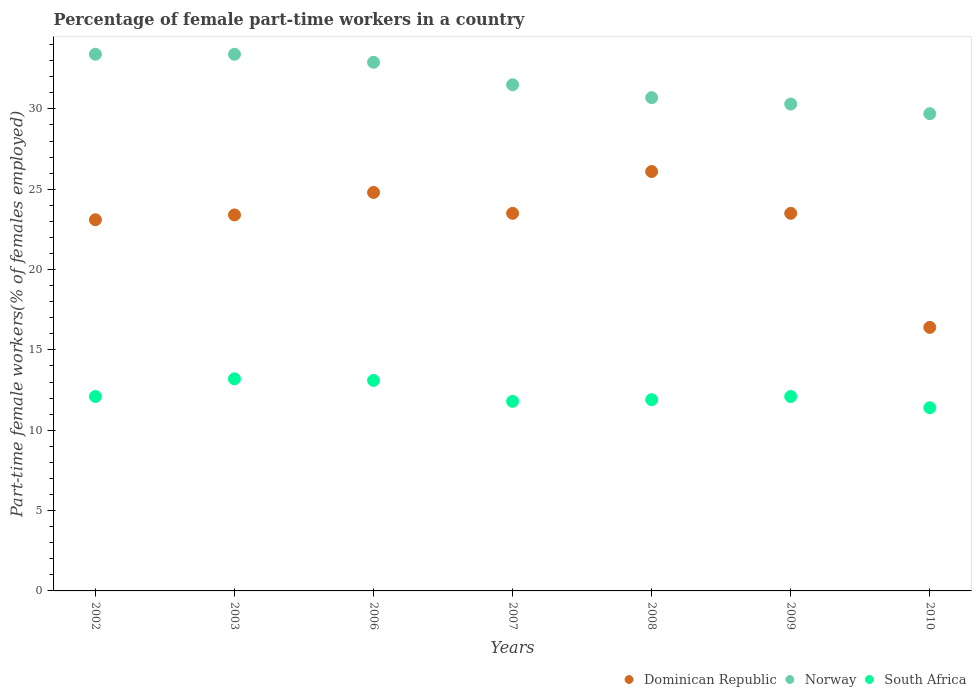How many different coloured dotlines are there?
Provide a succinct answer. 3. Is the number of dotlines equal to the number of legend labels?
Your answer should be compact. Yes. What is the percentage of female part-time workers in Norway in 2007?
Your response must be concise. 31.5. Across all years, what is the maximum percentage of female part-time workers in Norway?
Ensure brevity in your answer.  33.4. Across all years, what is the minimum percentage of female part-time workers in Norway?
Your answer should be compact. 29.7. In which year was the percentage of female part-time workers in Dominican Republic minimum?
Ensure brevity in your answer.  2010. What is the total percentage of female part-time workers in Norway in the graph?
Ensure brevity in your answer.  221.9. What is the difference between the percentage of female part-time workers in Dominican Republic in 2002 and that in 2008?
Ensure brevity in your answer.  -3. What is the difference between the percentage of female part-time workers in Norway in 2006 and the percentage of female part-time workers in South Africa in 2007?
Make the answer very short. 21.1. What is the average percentage of female part-time workers in Norway per year?
Offer a very short reply. 31.7. In the year 2002, what is the difference between the percentage of female part-time workers in Norway and percentage of female part-time workers in South Africa?
Provide a succinct answer. 21.3. What is the ratio of the percentage of female part-time workers in South Africa in 2003 to that in 2010?
Your response must be concise. 1.16. Is the percentage of female part-time workers in South Africa in 2002 less than that in 2009?
Your answer should be very brief. No. Is the difference between the percentage of female part-time workers in Norway in 2003 and 2007 greater than the difference between the percentage of female part-time workers in South Africa in 2003 and 2007?
Your answer should be very brief. Yes. What is the difference between the highest and the second highest percentage of female part-time workers in South Africa?
Provide a succinct answer. 0.1. What is the difference between the highest and the lowest percentage of female part-time workers in South Africa?
Offer a terse response. 1.8. Is the sum of the percentage of female part-time workers in Dominican Republic in 2003 and 2006 greater than the maximum percentage of female part-time workers in Norway across all years?
Your response must be concise. Yes. Is it the case that in every year, the sum of the percentage of female part-time workers in Norway and percentage of female part-time workers in South Africa  is greater than the percentage of female part-time workers in Dominican Republic?
Provide a short and direct response. Yes. Does the percentage of female part-time workers in South Africa monotonically increase over the years?
Your answer should be compact. No. Is the percentage of female part-time workers in South Africa strictly less than the percentage of female part-time workers in Norway over the years?
Keep it short and to the point. Yes. Are the values on the major ticks of Y-axis written in scientific E-notation?
Make the answer very short. No. Where does the legend appear in the graph?
Your answer should be very brief. Bottom right. How many legend labels are there?
Offer a terse response. 3. How are the legend labels stacked?
Your answer should be compact. Horizontal. What is the title of the graph?
Your response must be concise. Percentage of female part-time workers in a country. Does "Canada" appear as one of the legend labels in the graph?
Your response must be concise. No. What is the label or title of the Y-axis?
Offer a very short reply. Part-time female workers(% of females employed). What is the Part-time female workers(% of females employed) of Dominican Republic in 2002?
Ensure brevity in your answer.  23.1. What is the Part-time female workers(% of females employed) in Norway in 2002?
Your answer should be very brief. 33.4. What is the Part-time female workers(% of females employed) in South Africa in 2002?
Ensure brevity in your answer.  12.1. What is the Part-time female workers(% of females employed) in Dominican Republic in 2003?
Give a very brief answer. 23.4. What is the Part-time female workers(% of females employed) in Norway in 2003?
Offer a very short reply. 33.4. What is the Part-time female workers(% of females employed) of South Africa in 2003?
Offer a very short reply. 13.2. What is the Part-time female workers(% of females employed) of Dominican Republic in 2006?
Provide a succinct answer. 24.8. What is the Part-time female workers(% of females employed) of Norway in 2006?
Give a very brief answer. 32.9. What is the Part-time female workers(% of females employed) of South Africa in 2006?
Give a very brief answer. 13.1. What is the Part-time female workers(% of females employed) in Dominican Republic in 2007?
Make the answer very short. 23.5. What is the Part-time female workers(% of females employed) in Norway in 2007?
Provide a short and direct response. 31.5. What is the Part-time female workers(% of females employed) in South Africa in 2007?
Offer a very short reply. 11.8. What is the Part-time female workers(% of females employed) of Dominican Republic in 2008?
Provide a short and direct response. 26.1. What is the Part-time female workers(% of females employed) of Norway in 2008?
Your answer should be very brief. 30.7. What is the Part-time female workers(% of females employed) in South Africa in 2008?
Provide a succinct answer. 11.9. What is the Part-time female workers(% of females employed) of Norway in 2009?
Provide a succinct answer. 30.3. What is the Part-time female workers(% of females employed) in South Africa in 2009?
Offer a very short reply. 12.1. What is the Part-time female workers(% of females employed) of Dominican Republic in 2010?
Offer a very short reply. 16.4. What is the Part-time female workers(% of females employed) in Norway in 2010?
Provide a short and direct response. 29.7. What is the Part-time female workers(% of females employed) of South Africa in 2010?
Give a very brief answer. 11.4. Across all years, what is the maximum Part-time female workers(% of females employed) of Dominican Republic?
Give a very brief answer. 26.1. Across all years, what is the maximum Part-time female workers(% of females employed) of Norway?
Your answer should be compact. 33.4. Across all years, what is the maximum Part-time female workers(% of females employed) of South Africa?
Your answer should be compact. 13.2. Across all years, what is the minimum Part-time female workers(% of females employed) of Dominican Republic?
Make the answer very short. 16.4. Across all years, what is the minimum Part-time female workers(% of females employed) of Norway?
Give a very brief answer. 29.7. Across all years, what is the minimum Part-time female workers(% of females employed) of South Africa?
Provide a short and direct response. 11.4. What is the total Part-time female workers(% of females employed) of Dominican Republic in the graph?
Offer a very short reply. 160.8. What is the total Part-time female workers(% of females employed) of Norway in the graph?
Your response must be concise. 221.9. What is the total Part-time female workers(% of females employed) in South Africa in the graph?
Your answer should be compact. 85.6. What is the difference between the Part-time female workers(% of females employed) of Dominican Republic in 2002 and that in 2003?
Provide a short and direct response. -0.3. What is the difference between the Part-time female workers(% of females employed) of Norway in 2002 and that in 2003?
Give a very brief answer. 0. What is the difference between the Part-time female workers(% of females employed) of South Africa in 2002 and that in 2003?
Your response must be concise. -1.1. What is the difference between the Part-time female workers(% of females employed) in South Africa in 2002 and that in 2006?
Keep it short and to the point. -1. What is the difference between the Part-time female workers(% of females employed) in Dominican Republic in 2002 and that in 2007?
Keep it short and to the point. -0.4. What is the difference between the Part-time female workers(% of females employed) of South Africa in 2002 and that in 2007?
Give a very brief answer. 0.3. What is the difference between the Part-time female workers(% of females employed) of Dominican Republic in 2002 and that in 2008?
Offer a very short reply. -3. What is the difference between the Part-time female workers(% of females employed) of South Africa in 2002 and that in 2008?
Ensure brevity in your answer.  0.2. What is the difference between the Part-time female workers(% of females employed) of South Africa in 2002 and that in 2009?
Keep it short and to the point. 0. What is the difference between the Part-time female workers(% of females employed) in Dominican Republic in 2002 and that in 2010?
Give a very brief answer. 6.7. What is the difference between the Part-time female workers(% of females employed) of South Africa in 2002 and that in 2010?
Ensure brevity in your answer.  0.7. What is the difference between the Part-time female workers(% of females employed) in Dominican Republic in 2003 and that in 2007?
Make the answer very short. -0.1. What is the difference between the Part-time female workers(% of females employed) of Norway in 2003 and that in 2007?
Offer a very short reply. 1.9. What is the difference between the Part-time female workers(% of females employed) of Dominican Republic in 2003 and that in 2008?
Make the answer very short. -2.7. What is the difference between the Part-time female workers(% of females employed) in Norway in 2003 and that in 2009?
Ensure brevity in your answer.  3.1. What is the difference between the Part-time female workers(% of females employed) in Dominican Republic in 2003 and that in 2010?
Your answer should be very brief. 7. What is the difference between the Part-time female workers(% of females employed) of Norway in 2003 and that in 2010?
Your answer should be very brief. 3.7. What is the difference between the Part-time female workers(% of females employed) in Dominican Republic in 2006 and that in 2007?
Ensure brevity in your answer.  1.3. What is the difference between the Part-time female workers(% of females employed) of Dominican Republic in 2006 and that in 2008?
Your answer should be compact. -1.3. What is the difference between the Part-time female workers(% of females employed) of South Africa in 2006 and that in 2008?
Your answer should be very brief. 1.2. What is the difference between the Part-time female workers(% of females employed) of Dominican Republic in 2006 and that in 2009?
Ensure brevity in your answer.  1.3. What is the difference between the Part-time female workers(% of females employed) of Dominican Republic in 2007 and that in 2008?
Offer a terse response. -2.6. What is the difference between the Part-time female workers(% of females employed) of Norway in 2007 and that in 2008?
Your answer should be compact. 0.8. What is the difference between the Part-time female workers(% of females employed) in Norway in 2007 and that in 2009?
Make the answer very short. 1.2. What is the difference between the Part-time female workers(% of females employed) of Norway in 2008 and that in 2009?
Provide a short and direct response. 0.4. What is the difference between the Part-time female workers(% of females employed) in South Africa in 2008 and that in 2010?
Provide a succinct answer. 0.5. What is the difference between the Part-time female workers(% of females employed) in Dominican Republic in 2009 and that in 2010?
Offer a terse response. 7.1. What is the difference between the Part-time female workers(% of females employed) of Norway in 2009 and that in 2010?
Keep it short and to the point. 0.6. What is the difference between the Part-time female workers(% of females employed) of South Africa in 2009 and that in 2010?
Your answer should be compact. 0.7. What is the difference between the Part-time female workers(% of females employed) in Dominican Republic in 2002 and the Part-time female workers(% of females employed) in Norway in 2003?
Provide a short and direct response. -10.3. What is the difference between the Part-time female workers(% of females employed) in Dominican Republic in 2002 and the Part-time female workers(% of females employed) in South Africa in 2003?
Give a very brief answer. 9.9. What is the difference between the Part-time female workers(% of females employed) of Norway in 2002 and the Part-time female workers(% of females employed) of South Africa in 2003?
Offer a terse response. 20.2. What is the difference between the Part-time female workers(% of females employed) of Dominican Republic in 2002 and the Part-time female workers(% of females employed) of Norway in 2006?
Ensure brevity in your answer.  -9.8. What is the difference between the Part-time female workers(% of females employed) in Norway in 2002 and the Part-time female workers(% of females employed) in South Africa in 2006?
Offer a very short reply. 20.3. What is the difference between the Part-time female workers(% of females employed) in Dominican Republic in 2002 and the Part-time female workers(% of females employed) in South Africa in 2007?
Your response must be concise. 11.3. What is the difference between the Part-time female workers(% of females employed) in Norway in 2002 and the Part-time female workers(% of females employed) in South Africa in 2007?
Your answer should be compact. 21.6. What is the difference between the Part-time female workers(% of females employed) in Dominican Republic in 2002 and the Part-time female workers(% of females employed) in Norway in 2008?
Make the answer very short. -7.6. What is the difference between the Part-time female workers(% of females employed) of Dominican Republic in 2002 and the Part-time female workers(% of females employed) of Norway in 2009?
Your answer should be compact. -7.2. What is the difference between the Part-time female workers(% of females employed) of Norway in 2002 and the Part-time female workers(% of females employed) of South Africa in 2009?
Give a very brief answer. 21.3. What is the difference between the Part-time female workers(% of females employed) in Dominican Republic in 2002 and the Part-time female workers(% of females employed) in South Africa in 2010?
Your answer should be compact. 11.7. What is the difference between the Part-time female workers(% of females employed) in Norway in 2003 and the Part-time female workers(% of females employed) in South Africa in 2006?
Offer a very short reply. 20.3. What is the difference between the Part-time female workers(% of females employed) of Norway in 2003 and the Part-time female workers(% of females employed) of South Africa in 2007?
Your response must be concise. 21.6. What is the difference between the Part-time female workers(% of females employed) in Dominican Republic in 2003 and the Part-time female workers(% of females employed) in South Africa in 2008?
Your response must be concise. 11.5. What is the difference between the Part-time female workers(% of females employed) in Norway in 2003 and the Part-time female workers(% of females employed) in South Africa in 2008?
Your answer should be compact. 21.5. What is the difference between the Part-time female workers(% of females employed) of Dominican Republic in 2003 and the Part-time female workers(% of females employed) of Norway in 2009?
Offer a very short reply. -6.9. What is the difference between the Part-time female workers(% of females employed) of Dominican Republic in 2003 and the Part-time female workers(% of females employed) of South Africa in 2009?
Ensure brevity in your answer.  11.3. What is the difference between the Part-time female workers(% of females employed) in Norway in 2003 and the Part-time female workers(% of females employed) in South Africa in 2009?
Make the answer very short. 21.3. What is the difference between the Part-time female workers(% of females employed) in Dominican Republic in 2003 and the Part-time female workers(% of females employed) in South Africa in 2010?
Ensure brevity in your answer.  12. What is the difference between the Part-time female workers(% of females employed) of Norway in 2003 and the Part-time female workers(% of females employed) of South Africa in 2010?
Ensure brevity in your answer.  22. What is the difference between the Part-time female workers(% of females employed) of Dominican Republic in 2006 and the Part-time female workers(% of females employed) of Norway in 2007?
Your answer should be very brief. -6.7. What is the difference between the Part-time female workers(% of females employed) of Norway in 2006 and the Part-time female workers(% of females employed) of South Africa in 2007?
Offer a terse response. 21.1. What is the difference between the Part-time female workers(% of females employed) in Dominican Republic in 2006 and the Part-time female workers(% of females employed) in Norway in 2008?
Ensure brevity in your answer.  -5.9. What is the difference between the Part-time female workers(% of females employed) of Dominican Republic in 2006 and the Part-time female workers(% of females employed) of South Africa in 2008?
Offer a very short reply. 12.9. What is the difference between the Part-time female workers(% of females employed) of Norway in 2006 and the Part-time female workers(% of females employed) of South Africa in 2008?
Give a very brief answer. 21. What is the difference between the Part-time female workers(% of females employed) in Dominican Republic in 2006 and the Part-time female workers(% of females employed) in Norway in 2009?
Offer a very short reply. -5.5. What is the difference between the Part-time female workers(% of females employed) of Norway in 2006 and the Part-time female workers(% of females employed) of South Africa in 2009?
Make the answer very short. 20.8. What is the difference between the Part-time female workers(% of females employed) of Norway in 2006 and the Part-time female workers(% of females employed) of South Africa in 2010?
Your response must be concise. 21.5. What is the difference between the Part-time female workers(% of females employed) of Dominican Republic in 2007 and the Part-time female workers(% of females employed) of Norway in 2008?
Your answer should be compact. -7.2. What is the difference between the Part-time female workers(% of females employed) of Norway in 2007 and the Part-time female workers(% of females employed) of South Africa in 2008?
Ensure brevity in your answer.  19.6. What is the difference between the Part-time female workers(% of females employed) in Dominican Republic in 2007 and the Part-time female workers(% of females employed) in Norway in 2009?
Provide a succinct answer. -6.8. What is the difference between the Part-time female workers(% of females employed) in Dominican Republic in 2007 and the Part-time female workers(% of females employed) in South Africa in 2009?
Offer a terse response. 11.4. What is the difference between the Part-time female workers(% of females employed) of Dominican Republic in 2007 and the Part-time female workers(% of females employed) of Norway in 2010?
Keep it short and to the point. -6.2. What is the difference between the Part-time female workers(% of females employed) of Norway in 2007 and the Part-time female workers(% of females employed) of South Africa in 2010?
Your response must be concise. 20.1. What is the difference between the Part-time female workers(% of females employed) of Dominican Republic in 2008 and the Part-time female workers(% of females employed) of Norway in 2009?
Offer a terse response. -4.2. What is the difference between the Part-time female workers(% of females employed) in Dominican Republic in 2008 and the Part-time female workers(% of females employed) in South Africa in 2010?
Make the answer very short. 14.7. What is the difference between the Part-time female workers(% of females employed) in Norway in 2008 and the Part-time female workers(% of females employed) in South Africa in 2010?
Offer a terse response. 19.3. What is the difference between the Part-time female workers(% of females employed) in Dominican Republic in 2009 and the Part-time female workers(% of females employed) in Norway in 2010?
Your answer should be compact. -6.2. What is the average Part-time female workers(% of females employed) in Dominican Republic per year?
Your response must be concise. 22.97. What is the average Part-time female workers(% of females employed) in Norway per year?
Offer a terse response. 31.7. What is the average Part-time female workers(% of females employed) of South Africa per year?
Provide a short and direct response. 12.23. In the year 2002, what is the difference between the Part-time female workers(% of females employed) of Dominican Republic and Part-time female workers(% of females employed) of South Africa?
Make the answer very short. 11. In the year 2002, what is the difference between the Part-time female workers(% of females employed) of Norway and Part-time female workers(% of females employed) of South Africa?
Your answer should be compact. 21.3. In the year 2003, what is the difference between the Part-time female workers(% of females employed) in Norway and Part-time female workers(% of females employed) in South Africa?
Make the answer very short. 20.2. In the year 2006, what is the difference between the Part-time female workers(% of females employed) of Dominican Republic and Part-time female workers(% of females employed) of South Africa?
Provide a short and direct response. 11.7. In the year 2006, what is the difference between the Part-time female workers(% of females employed) in Norway and Part-time female workers(% of females employed) in South Africa?
Make the answer very short. 19.8. In the year 2007, what is the difference between the Part-time female workers(% of females employed) of Dominican Republic and Part-time female workers(% of females employed) of South Africa?
Keep it short and to the point. 11.7. In the year 2009, what is the difference between the Part-time female workers(% of females employed) of Dominican Republic and Part-time female workers(% of females employed) of South Africa?
Provide a short and direct response. 11.4. In the year 2009, what is the difference between the Part-time female workers(% of females employed) of Norway and Part-time female workers(% of females employed) of South Africa?
Give a very brief answer. 18.2. In the year 2010, what is the difference between the Part-time female workers(% of females employed) of Dominican Republic and Part-time female workers(% of females employed) of Norway?
Provide a short and direct response. -13.3. In the year 2010, what is the difference between the Part-time female workers(% of females employed) in Dominican Republic and Part-time female workers(% of females employed) in South Africa?
Your answer should be very brief. 5. In the year 2010, what is the difference between the Part-time female workers(% of females employed) in Norway and Part-time female workers(% of females employed) in South Africa?
Keep it short and to the point. 18.3. What is the ratio of the Part-time female workers(% of females employed) of Dominican Republic in 2002 to that in 2003?
Offer a very short reply. 0.99. What is the ratio of the Part-time female workers(% of females employed) in Norway in 2002 to that in 2003?
Your answer should be very brief. 1. What is the ratio of the Part-time female workers(% of females employed) in Dominican Republic in 2002 to that in 2006?
Your answer should be compact. 0.93. What is the ratio of the Part-time female workers(% of females employed) of Norway in 2002 to that in 2006?
Your response must be concise. 1.02. What is the ratio of the Part-time female workers(% of females employed) of South Africa in 2002 to that in 2006?
Provide a short and direct response. 0.92. What is the ratio of the Part-time female workers(% of females employed) in Norway in 2002 to that in 2007?
Give a very brief answer. 1.06. What is the ratio of the Part-time female workers(% of females employed) in South Africa in 2002 to that in 2007?
Provide a succinct answer. 1.03. What is the ratio of the Part-time female workers(% of females employed) in Dominican Republic in 2002 to that in 2008?
Your answer should be compact. 0.89. What is the ratio of the Part-time female workers(% of females employed) of Norway in 2002 to that in 2008?
Offer a terse response. 1.09. What is the ratio of the Part-time female workers(% of females employed) in South Africa in 2002 to that in 2008?
Your answer should be very brief. 1.02. What is the ratio of the Part-time female workers(% of females employed) in Dominican Republic in 2002 to that in 2009?
Your response must be concise. 0.98. What is the ratio of the Part-time female workers(% of females employed) of Norway in 2002 to that in 2009?
Offer a very short reply. 1.1. What is the ratio of the Part-time female workers(% of females employed) in South Africa in 2002 to that in 2009?
Provide a short and direct response. 1. What is the ratio of the Part-time female workers(% of females employed) of Dominican Republic in 2002 to that in 2010?
Ensure brevity in your answer.  1.41. What is the ratio of the Part-time female workers(% of females employed) in Norway in 2002 to that in 2010?
Keep it short and to the point. 1.12. What is the ratio of the Part-time female workers(% of females employed) in South Africa in 2002 to that in 2010?
Ensure brevity in your answer.  1.06. What is the ratio of the Part-time female workers(% of females employed) in Dominican Republic in 2003 to that in 2006?
Make the answer very short. 0.94. What is the ratio of the Part-time female workers(% of females employed) in Norway in 2003 to that in 2006?
Provide a short and direct response. 1.02. What is the ratio of the Part-time female workers(% of females employed) in South Africa in 2003 to that in 2006?
Provide a succinct answer. 1.01. What is the ratio of the Part-time female workers(% of females employed) in Norway in 2003 to that in 2007?
Provide a succinct answer. 1.06. What is the ratio of the Part-time female workers(% of females employed) in South Africa in 2003 to that in 2007?
Your answer should be compact. 1.12. What is the ratio of the Part-time female workers(% of females employed) of Dominican Republic in 2003 to that in 2008?
Your answer should be very brief. 0.9. What is the ratio of the Part-time female workers(% of females employed) of Norway in 2003 to that in 2008?
Provide a succinct answer. 1.09. What is the ratio of the Part-time female workers(% of females employed) in South Africa in 2003 to that in 2008?
Your answer should be very brief. 1.11. What is the ratio of the Part-time female workers(% of females employed) in Norway in 2003 to that in 2009?
Offer a terse response. 1.1. What is the ratio of the Part-time female workers(% of females employed) in Dominican Republic in 2003 to that in 2010?
Give a very brief answer. 1.43. What is the ratio of the Part-time female workers(% of females employed) of Norway in 2003 to that in 2010?
Keep it short and to the point. 1.12. What is the ratio of the Part-time female workers(% of females employed) in South Africa in 2003 to that in 2010?
Your answer should be very brief. 1.16. What is the ratio of the Part-time female workers(% of females employed) of Dominican Republic in 2006 to that in 2007?
Offer a terse response. 1.06. What is the ratio of the Part-time female workers(% of females employed) in Norway in 2006 to that in 2007?
Provide a short and direct response. 1.04. What is the ratio of the Part-time female workers(% of females employed) of South Africa in 2006 to that in 2007?
Provide a succinct answer. 1.11. What is the ratio of the Part-time female workers(% of females employed) of Dominican Republic in 2006 to that in 2008?
Your response must be concise. 0.95. What is the ratio of the Part-time female workers(% of females employed) of Norway in 2006 to that in 2008?
Your response must be concise. 1.07. What is the ratio of the Part-time female workers(% of females employed) in South Africa in 2006 to that in 2008?
Make the answer very short. 1.1. What is the ratio of the Part-time female workers(% of females employed) of Dominican Republic in 2006 to that in 2009?
Provide a short and direct response. 1.06. What is the ratio of the Part-time female workers(% of females employed) in Norway in 2006 to that in 2009?
Your answer should be compact. 1.09. What is the ratio of the Part-time female workers(% of females employed) in South Africa in 2006 to that in 2009?
Offer a very short reply. 1.08. What is the ratio of the Part-time female workers(% of females employed) of Dominican Republic in 2006 to that in 2010?
Give a very brief answer. 1.51. What is the ratio of the Part-time female workers(% of females employed) in Norway in 2006 to that in 2010?
Your answer should be very brief. 1.11. What is the ratio of the Part-time female workers(% of females employed) of South Africa in 2006 to that in 2010?
Keep it short and to the point. 1.15. What is the ratio of the Part-time female workers(% of females employed) in Dominican Republic in 2007 to that in 2008?
Offer a very short reply. 0.9. What is the ratio of the Part-time female workers(% of females employed) in Norway in 2007 to that in 2008?
Keep it short and to the point. 1.03. What is the ratio of the Part-time female workers(% of females employed) in South Africa in 2007 to that in 2008?
Offer a terse response. 0.99. What is the ratio of the Part-time female workers(% of females employed) of Norway in 2007 to that in 2009?
Offer a very short reply. 1.04. What is the ratio of the Part-time female workers(% of females employed) of South Africa in 2007 to that in 2009?
Give a very brief answer. 0.98. What is the ratio of the Part-time female workers(% of females employed) in Dominican Republic in 2007 to that in 2010?
Provide a short and direct response. 1.43. What is the ratio of the Part-time female workers(% of females employed) of Norway in 2007 to that in 2010?
Provide a succinct answer. 1.06. What is the ratio of the Part-time female workers(% of females employed) of South Africa in 2007 to that in 2010?
Your answer should be very brief. 1.04. What is the ratio of the Part-time female workers(% of females employed) of Dominican Republic in 2008 to that in 2009?
Provide a succinct answer. 1.11. What is the ratio of the Part-time female workers(% of females employed) of Norway in 2008 to that in 2009?
Your answer should be compact. 1.01. What is the ratio of the Part-time female workers(% of females employed) in South Africa in 2008 to that in 2009?
Give a very brief answer. 0.98. What is the ratio of the Part-time female workers(% of females employed) in Dominican Republic in 2008 to that in 2010?
Your answer should be compact. 1.59. What is the ratio of the Part-time female workers(% of females employed) of Norway in 2008 to that in 2010?
Offer a very short reply. 1.03. What is the ratio of the Part-time female workers(% of females employed) of South Africa in 2008 to that in 2010?
Your answer should be very brief. 1.04. What is the ratio of the Part-time female workers(% of females employed) in Dominican Republic in 2009 to that in 2010?
Your answer should be compact. 1.43. What is the ratio of the Part-time female workers(% of females employed) in Norway in 2009 to that in 2010?
Your answer should be very brief. 1.02. What is the ratio of the Part-time female workers(% of females employed) of South Africa in 2009 to that in 2010?
Provide a succinct answer. 1.06. What is the difference between the highest and the second highest Part-time female workers(% of females employed) in Norway?
Provide a succinct answer. 0. What is the difference between the highest and the lowest Part-time female workers(% of females employed) of Norway?
Give a very brief answer. 3.7. 